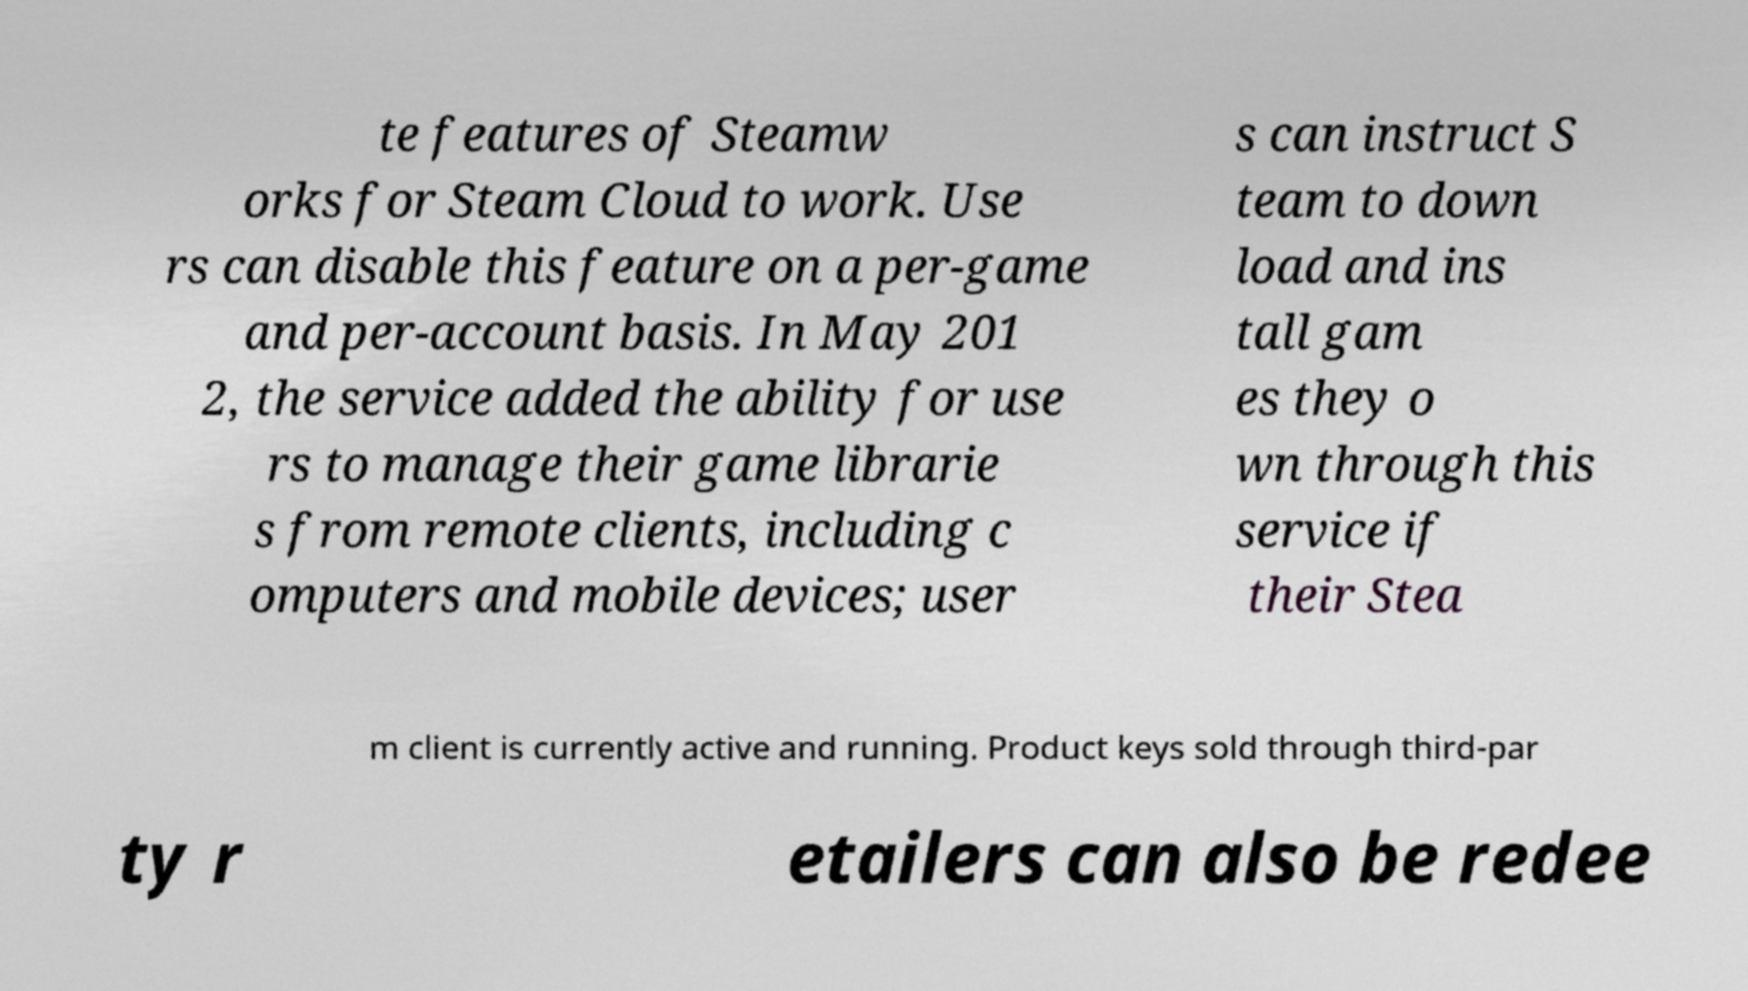There's text embedded in this image that I need extracted. Can you transcribe it verbatim? te features of Steamw orks for Steam Cloud to work. Use rs can disable this feature on a per-game and per-account basis. In May 201 2, the service added the ability for use rs to manage their game librarie s from remote clients, including c omputers and mobile devices; user s can instruct S team to down load and ins tall gam es they o wn through this service if their Stea m client is currently active and running. Product keys sold through third-par ty r etailers can also be redee 